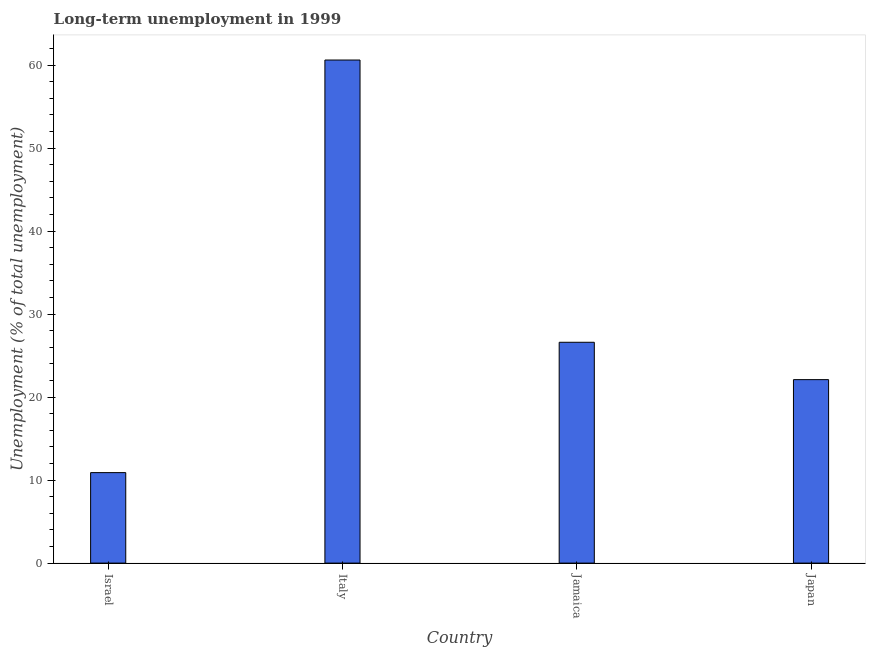Does the graph contain any zero values?
Your response must be concise. No. Does the graph contain grids?
Ensure brevity in your answer.  No. What is the title of the graph?
Your answer should be compact. Long-term unemployment in 1999. What is the label or title of the Y-axis?
Your answer should be compact. Unemployment (% of total unemployment). What is the long-term unemployment in Israel?
Offer a terse response. 10.9. Across all countries, what is the maximum long-term unemployment?
Ensure brevity in your answer.  60.6. Across all countries, what is the minimum long-term unemployment?
Keep it short and to the point. 10.9. In which country was the long-term unemployment minimum?
Your answer should be very brief. Israel. What is the sum of the long-term unemployment?
Give a very brief answer. 120.2. What is the difference between the long-term unemployment in Italy and Jamaica?
Give a very brief answer. 34. What is the average long-term unemployment per country?
Offer a terse response. 30.05. What is the median long-term unemployment?
Your answer should be compact. 24.35. In how many countries, is the long-term unemployment greater than 2 %?
Your answer should be compact. 4. What is the ratio of the long-term unemployment in Italy to that in Japan?
Your answer should be compact. 2.74. What is the difference between the highest and the second highest long-term unemployment?
Keep it short and to the point. 34. What is the difference between the highest and the lowest long-term unemployment?
Your answer should be very brief. 49.7. Are all the bars in the graph horizontal?
Provide a succinct answer. No. How many countries are there in the graph?
Provide a succinct answer. 4. What is the difference between two consecutive major ticks on the Y-axis?
Provide a short and direct response. 10. Are the values on the major ticks of Y-axis written in scientific E-notation?
Offer a very short reply. No. What is the Unemployment (% of total unemployment) of Israel?
Give a very brief answer. 10.9. What is the Unemployment (% of total unemployment) in Italy?
Your response must be concise. 60.6. What is the Unemployment (% of total unemployment) in Jamaica?
Offer a terse response. 26.6. What is the Unemployment (% of total unemployment) in Japan?
Your answer should be very brief. 22.1. What is the difference between the Unemployment (% of total unemployment) in Israel and Italy?
Your answer should be very brief. -49.7. What is the difference between the Unemployment (% of total unemployment) in Israel and Jamaica?
Keep it short and to the point. -15.7. What is the difference between the Unemployment (% of total unemployment) in Israel and Japan?
Provide a succinct answer. -11.2. What is the difference between the Unemployment (% of total unemployment) in Italy and Jamaica?
Give a very brief answer. 34. What is the difference between the Unemployment (% of total unemployment) in Italy and Japan?
Offer a very short reply. 38.5. What is the difference between the Unemployment (% of total unemployment) in Jamaica and Japan?
Make the answer very short. 4.5. What is the ratio of the Unemployment (% of total unemployment) in Israel to that in Italy?
Provide a short and direct response. 0.18. What is the ratio of the Unemployment (% of total unemployment) in Israel to that in Jamaica?
Make the answer very short. 0.41. What is the ratio of the Unemployment (% of total unemployment) in Israel to that in Japan?
Your response must be concise. 0.49. What is the ratio of the Unemployment (% of total unemployment) in Italy to that in Jamaica?
Your answer should be very brief. 2.28. What is the ratio of the Unemployment (% of total unemployment) in Italy to that in Japan?
Offer a terse response. 2.74. What is the ratio of the Unemployment (% of total unemployment) in Jamaica to that in Japan?
Your answer should be compact. 1.2. 